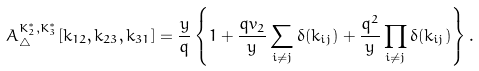<formula> <loc_0><loc_0><loc_500><loc_500>A ^ { K ^ { * } _ { 2 } , K ^ { * } _ { 3 } } _ { \bigtriangleup } [ k _ { 1 2 } , k _ { 2 3 } , k _ { 3 1 } ] = \frac { y } { q } \left \{ 1 + \frac { q v _ { 2 } } { y } \sum _ { i \neq j } \delta ( k _ { i j } ) + \frac { q ^ { 2 } } { y } \prod _ { i \neq j } \delta ( k _ { i j } ) \right \} .</formula> 